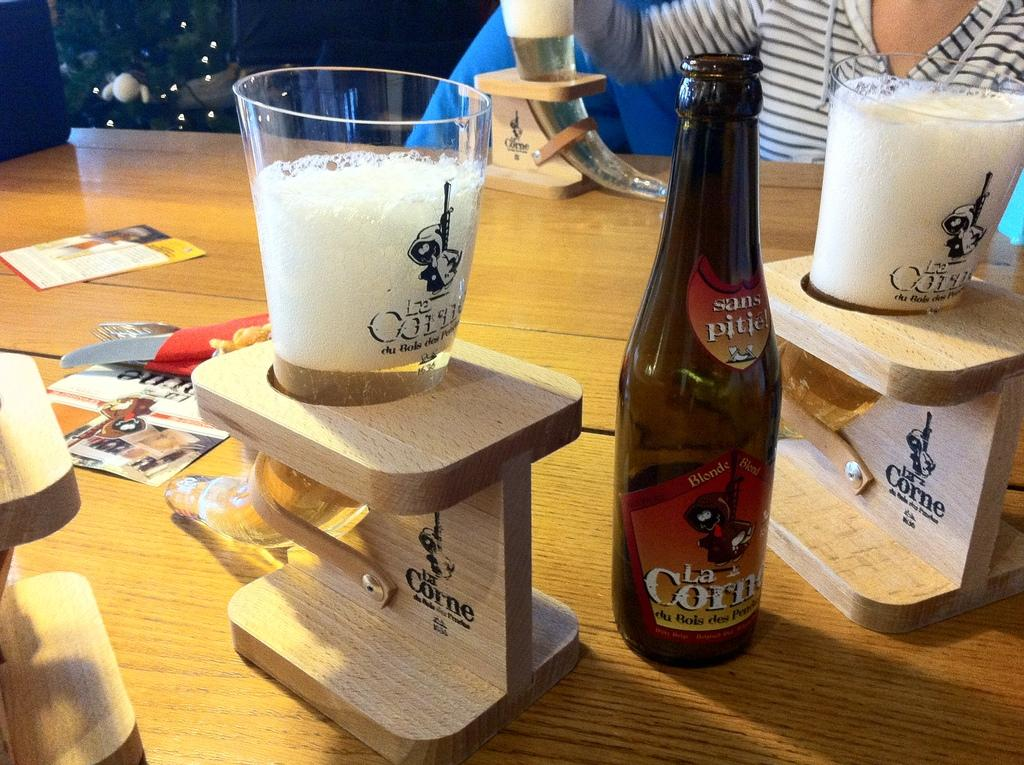<image>
Render a clear and concise summary of the photo. Two very foamy beer glasses sitting in elevated wooden coasters on either side of a bottle of sans pitie! La Corne beer. 